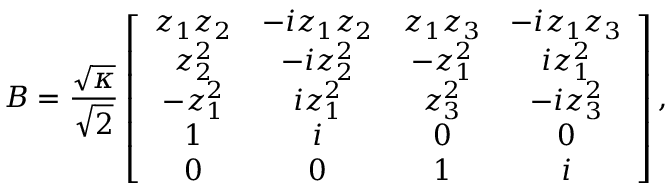Convert formula to latex. <formula><loc_0><loc_0><loc_500><loc_500>B = \frac { \sqrt { \kappa } } { \sqrt { 2 } } \left [ \begin{array} { c c c c } { z _ { 1 } z _ { 2 } } & { - i z _ { 1 } z _ { 2 } } & { z _ { 1 } z _ { 3 } } & { - i z _ { 1 } z _ { 3 } } \\ { z _ { 2 } ^ { 2 } } & { - i z _ { 2 } ^ { 2 } } & { - z _ { 1 } ^ { 2 } } & { i z _ { 1 } ^ { 2 } } \\ { - z _ { 1 } ^ { 2 } } & { i z _ { 1 } ^ { 2 } } & { z _ { 3 } ^ { 2 } } & { - i z _ { 3 } ^ { 2 } } \\ { 1 } & { i } & { 0 } & { 0 } \\ { 0 } & { 0 } & { 1 } & { i } \end{array} \right ] ,</formula> 